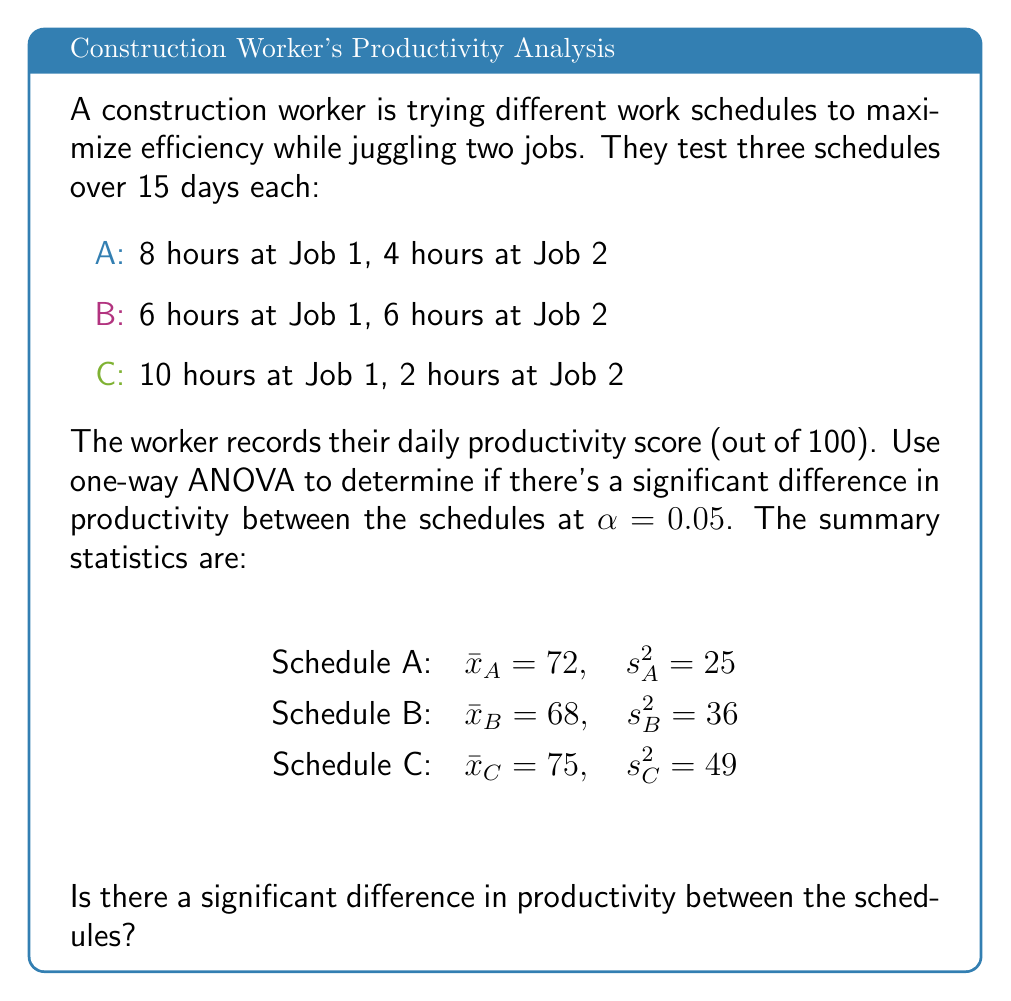Can you solve this math problem? To solve this problem using one-way ANOVA, we'll follow these steps:

1) State the hypotheses:
   $H_0$: $\mu_A = \mu_B = \mu_C$ (no difference between schedules)
   $H_1$: At least one mean is different

2) Calculate the between-group sum of squares (SSB):
   $$SSB = n\sum_{i=1}^k (\bar{x}_i - \bar{x})^2$$
   where $n = 15$ (days per schedule), $k = 3$ (number of schedules)
   
   First, calculate the grand mean:
   $$\bar{x} = \frac{72 + 68 + 75}{3} = 71.67$$
   
   Then:
   $$SSB = 15[(72 - 71.67)^2 + (68 - 71.67)^2 + (75 - 71.67)^2] = 367.5$$

3) Calculate the within-group sum of squares (SSW):
   $$SSW = (n-1)\sum_{i=1}^k s_i^2$$
   $$SSW = 14(25 + 36 + 49) = 1540$$

4) Calculate the total sum of squares (SST):
   $$SST = SSB + SSW = 367.5 + 1540 = 1907.5$$

5) Calculate degrees of freedom:
   $df_{between} = k - 1 = 2$
   $df_{within} = k(n-1) = 42$
   $df_{total} = kn - 1 = 44$

6) Calculate mean squares:
   $$MSB = \frac{SSB}{df_{between}} = \frac{367.5}{2} = 183.75$$
   $$MSW = \frac{SSW}{df_{within}} = \frac{1540}{42} = 36.67$$

7) Calculate F-statistic:
   $$F = \frac{MSB}{MSW} = \frac{183.75}{36.67} = 5.01$$

8) Find the critical F-value:
   For $\alpha = 0.05$, $df_{between} = 2$, and $df_{within} = 42$,
   $F_{crit} = 3.22$ (from F-distribution table)

9) Compare F to F_{crit}:
   Since $F = 5.01 > F_{crit} = 3.22$, we reject the null hypothesis.
Answer: Yes, there is a significant difference in productivity between the schedules (F = 5.01, p < 0.05). 